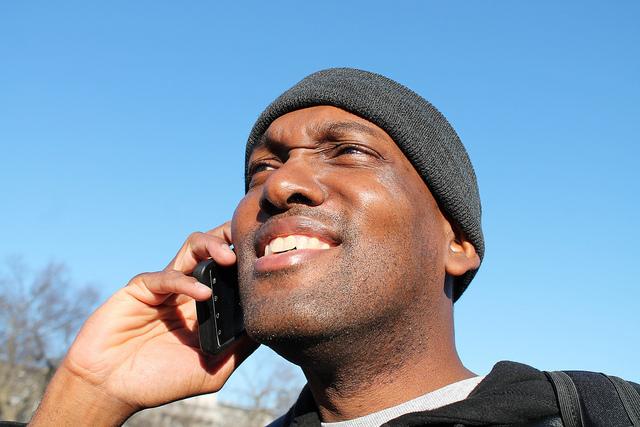What is the man doing in the picture?
Concise answer only. Talking on phone. With which hand is he holding his phone?
Short answer required. Right. What color is the man's hat?
Answer briefly. Gray. 